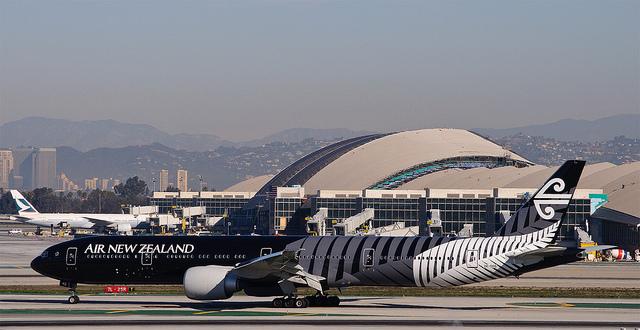Where is this plane going?
Be succinct. New zealand. Does the plane look like a zebra?
Answer briefly. Yes. Does the plane have stripes?
Concise answer only. Yes. 